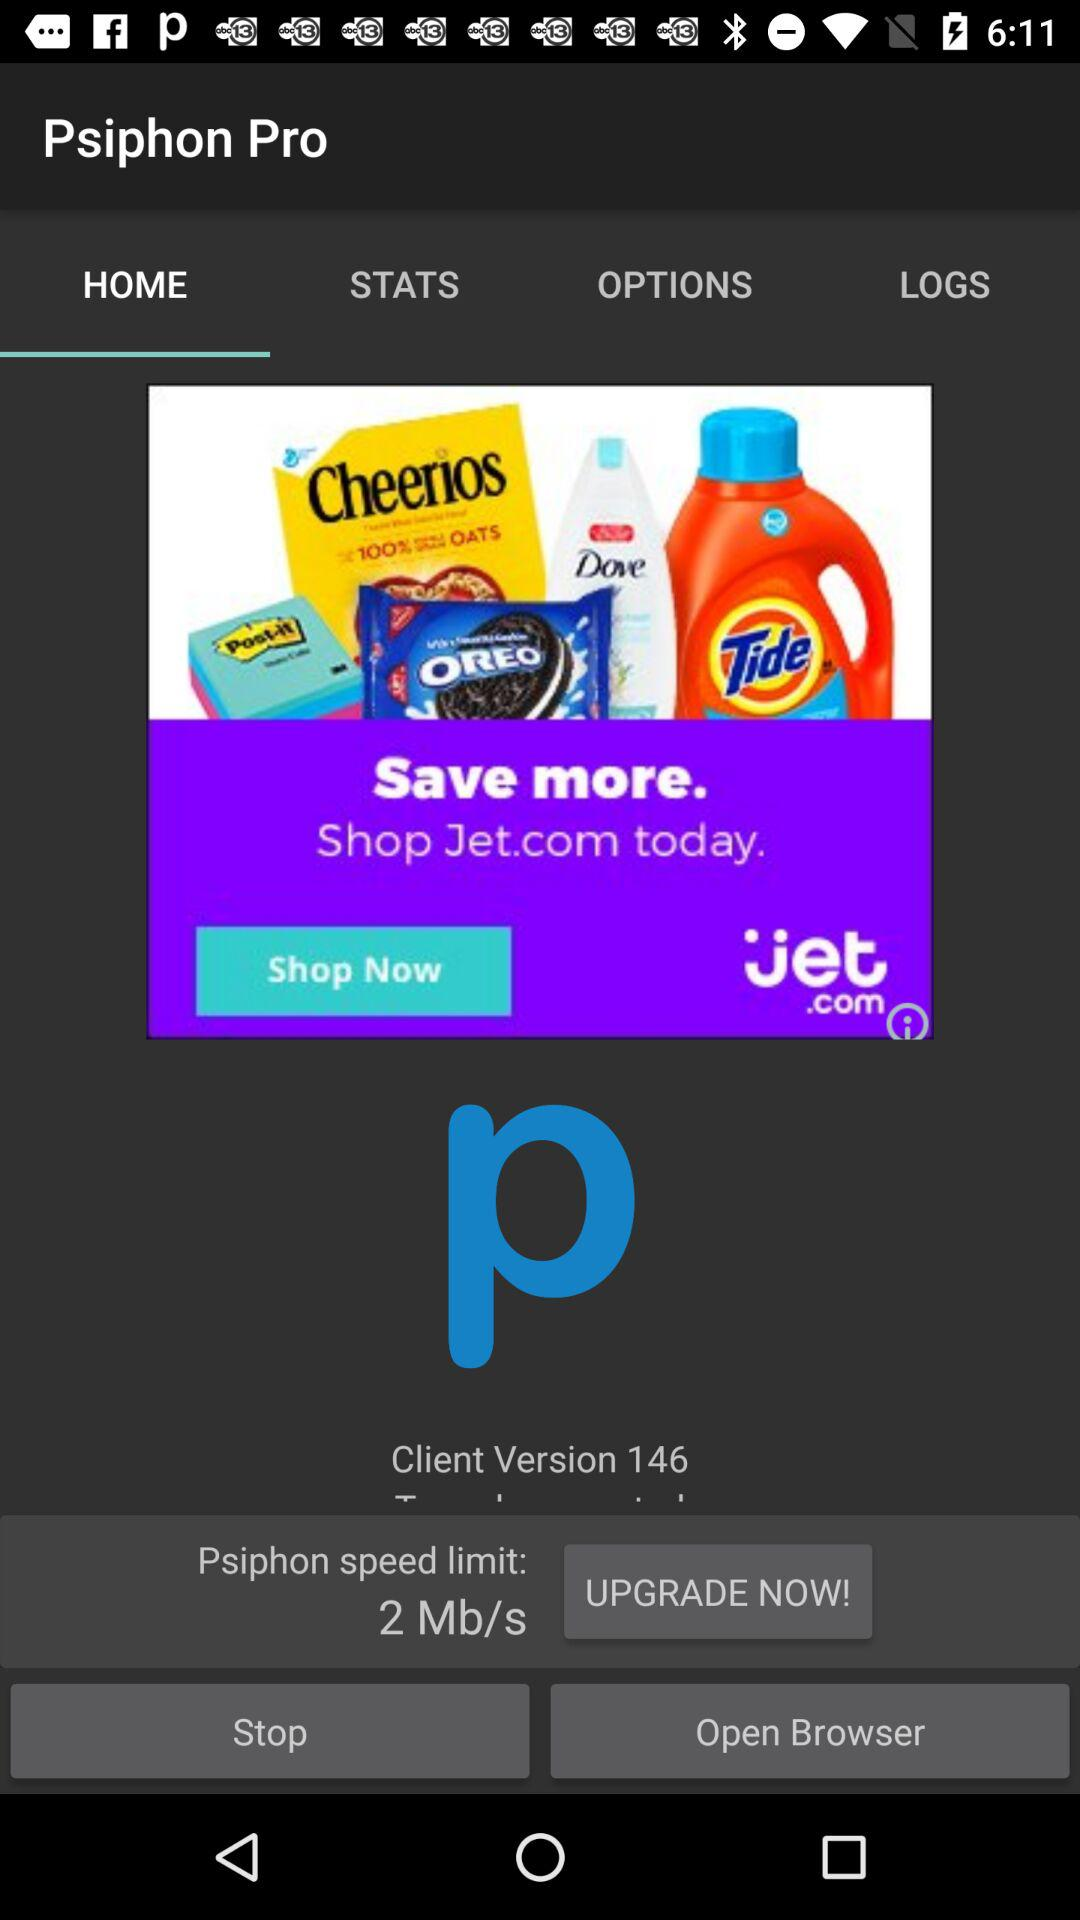Which tab is selected? The selected tab is "HOME". 